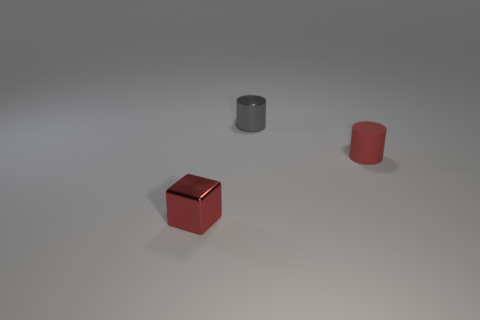Add 2 metallic cylinders. How many objects exist? 5 Subtract all blocks. How many objects are left? 2 Subtract 1 gray cylinders. How many objects are left? 2 Subtract all matte blocks. Subtract all gray cylinders. How many objects are left? 2 Add 3 cubes. How many cubes are left? 4 Add 1 cyan matte spheres. How many cyan matte spheres exist? 1 